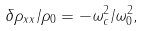Convert formula to latex. <formula><loc_0><loc_0><loc_500><loc_500>\delta \rho _ { x x } / \rho _ { 0 } = - \omega _ { c } ^ { 2 } / \omega _ { 0 } ^ { 2 } ,</formula> 